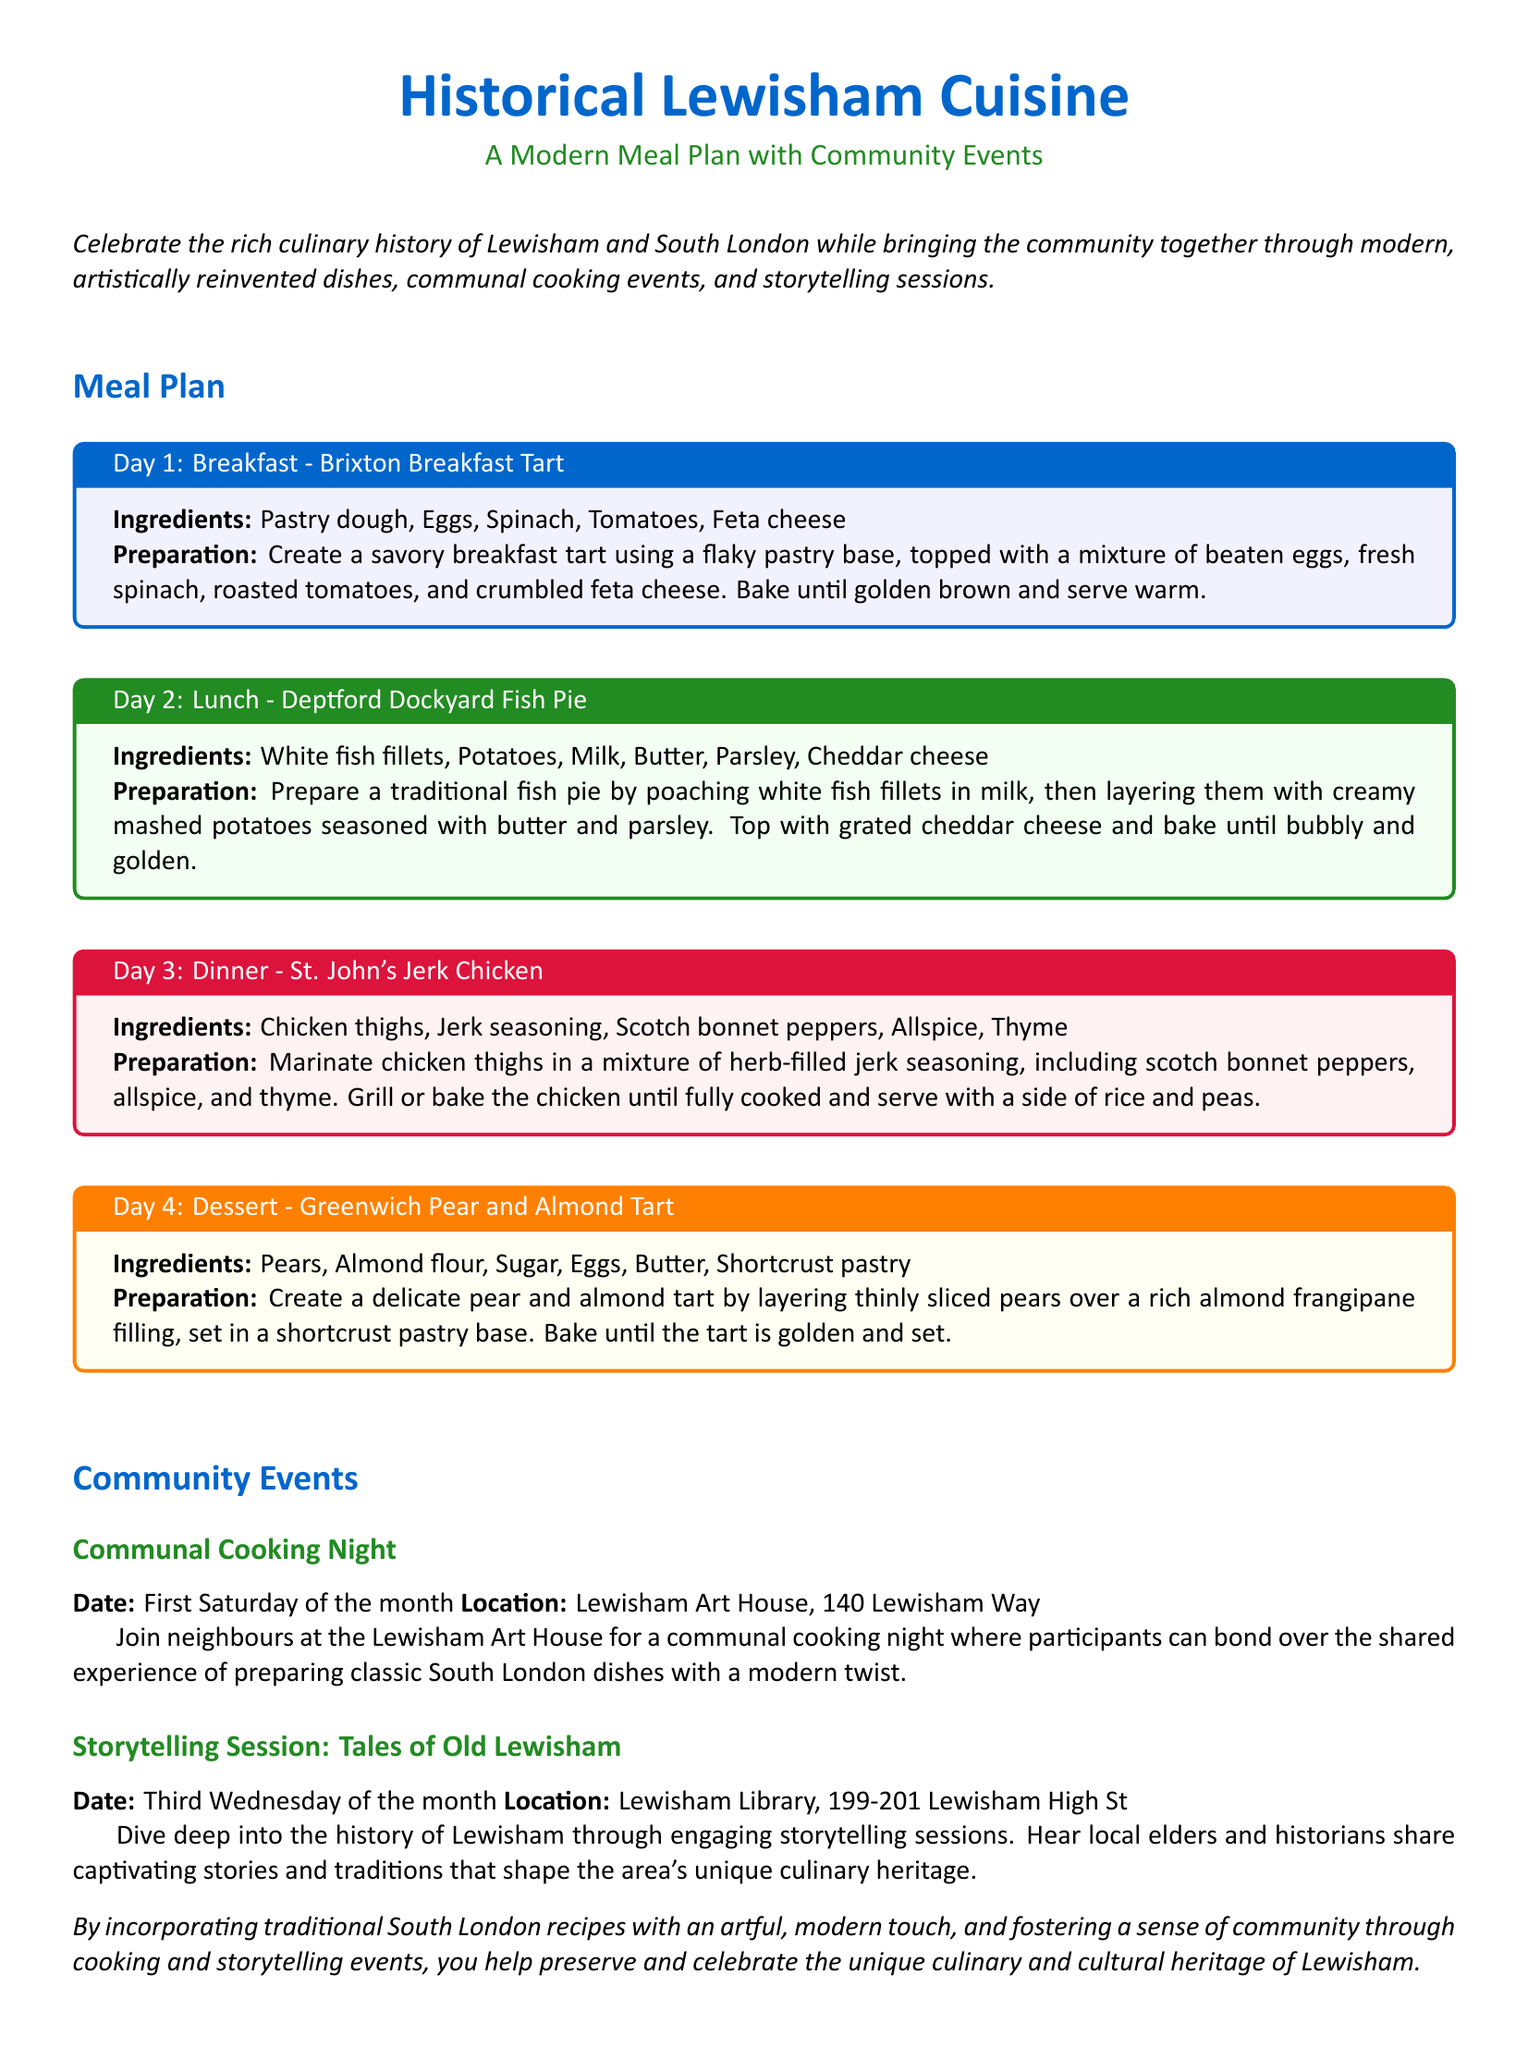What is the title of the meal plan? The title of the meal plan is prominently displayed at the beginning of the document as "Historical Lewisham Cuisine."
Answer: Historical Lewisham Cuisine What is the first meal listed in the meal plan? The first meal listed under the meal plan is the breakfast for Day 1.
Answer: Brixton Breakfast Tart What are the main ingredients for the fish pie? The ingredients for the Deptford Dockyard Fish Pie are listed in the respective section of the document.
Answer: White fish fillets, Potatoes, Milk, Butter, Parsley, Cheddar cheese When is the communal cooking night scheduled? The communal cooking night is scheduled for the first Saturday of the month, as stated in the community events section.
Answer: First Saturday of the month Where does the storytelling session take place? The location of the storytelling session is provided in the document, specifying where it will occur.
Answer: Lewisham Library, 199-201 Lewisham High St What type of dish is served for dinner on Day 3? The type of dish mentioned for dinner on Day 3 can be inferred from the section detailing Day 3's meal.
Answer: Jerk Chicken How many communal cooking nights are mentioned in the document? The document mentions only one communal cooking night in the community events section.
Answer: One What is the dessert listed in the meal plan? The dessert is listed as the final dish in the sequence of meals provided in the meal plan.
Answer: Greenwich Pear and Almond Tart 